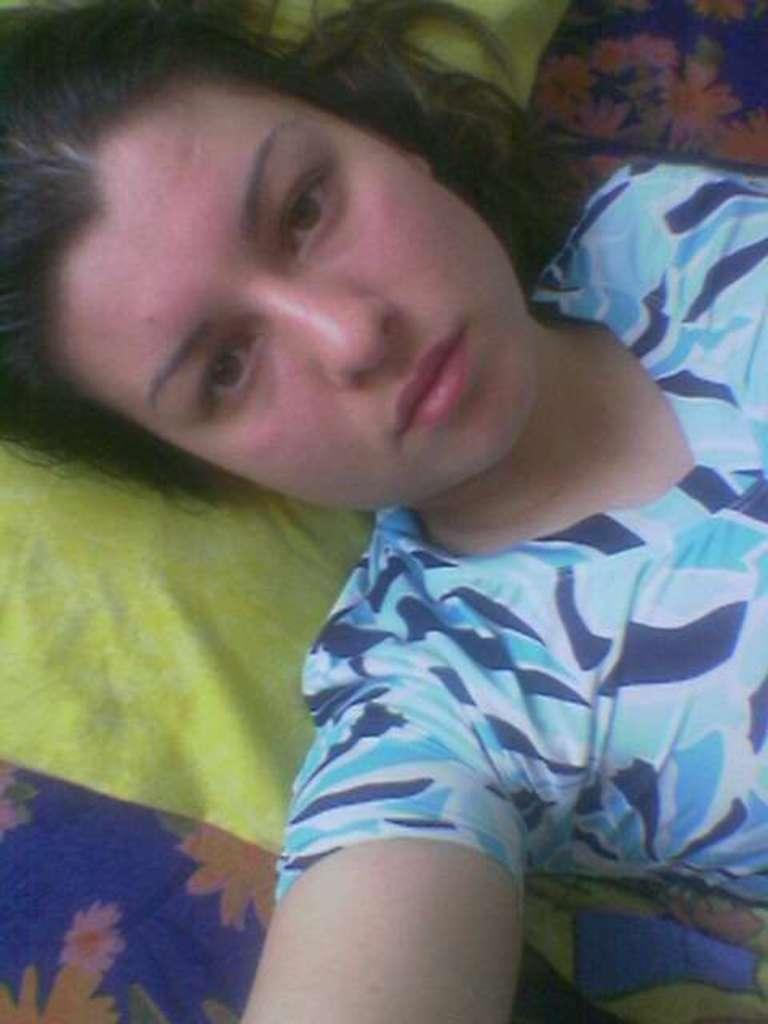Who is in the image? There is a woman in the image. What is the woman doing in the image? The woman is lying on a bed. Can you describe the bed in the image? The bed is blue in color and has a flower design on it. What is the woman wearing in the image? The woman is wearing a blue dress. Can you describe the dress in more detail? The blue dress has dark blue designs on it. What type of bait is the woman using to catch fish in the image? There is no mention of fishing or bait in the image; it features a woman lying on a bed with a blue dress. What is the woman writing in the image? There is no indication that the woman is writing in the image. 